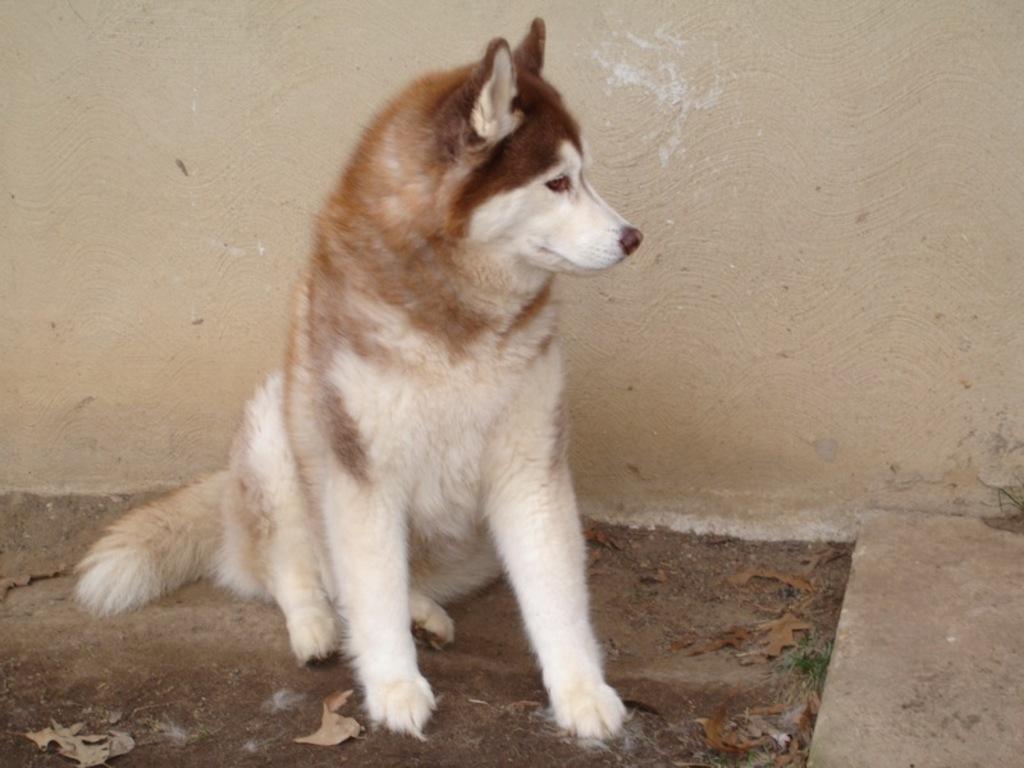Please provide a concise description of this image. In this image I can see a white and brown colour dog in the front. I can also see the wall in the background and on the ground I can see few leaves. 